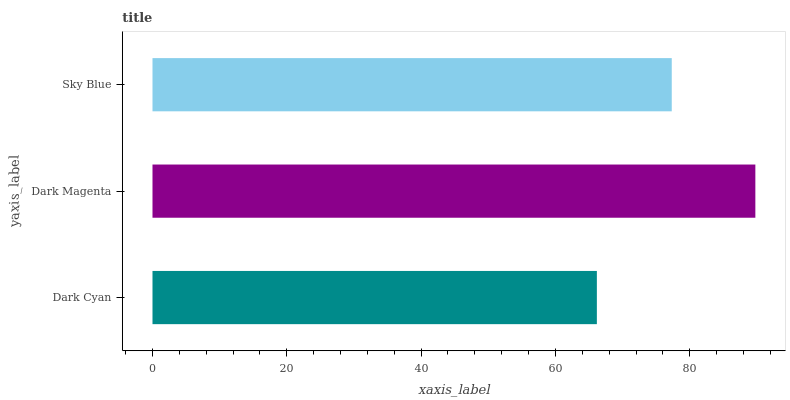Is Dark Cyan the minimum?
Answer yes or no. Yes. Is Dark Magenta the maximum?
Answer yes or no. Yes. Is Sky Blue the minimum?
Answer yes or no. No. Is Sky Blue the maximum?
Answer yes or no. No. Is Dark Magenta greater than Sky Blue?
Answer yes or no. Yes. Is Sky Blue less than Dark Magenta?
Answer yes or no. Yes. Is Sky Blue greater than Dark Magenta?
Answer yes or no. No. Is Dark Magenta less than Sky Blue?
Answer yes or no. No. Is Sky Blue the high median?
Answer yes or no. Yes. Is Sky Blue the low median?
Answer yes or no. Yes. Is Dark Magenta the high median?
Answer yes or no. No. Is Dark Magenta the low median?
Answer yes or no. No. 